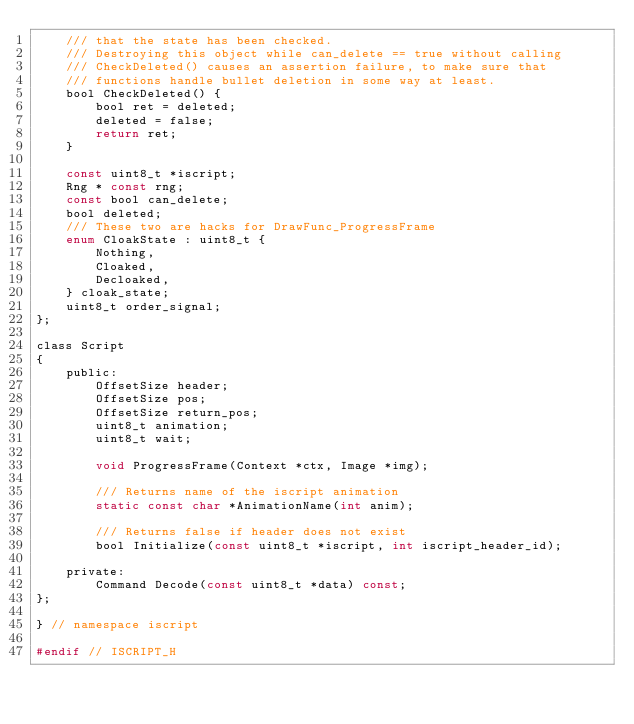<code> <loc_0><loc_0><loc_500><loc_500><_C_>    /// that the state has been checked.
    /// Destroying this object while can_delete == true without calling
    /// CheckDeleted() causes an assertion failure, to make sure that
    /// functions handle bullet deletion in some way at least.
    bool CheckDeleted() {
        bool ret = deleted;
        deleted = false;
        return ret;
    }

    const uint8_t *iscript;
    Rng * const rng;
    const bool can_delete;
    bool deleted;
    /// These two are hacks for DrawFunc_ProgressFrame
    enum CloakState : uint8_t {
        Nothing,
        Cloaked,
        Decloaked,
    } cloak_state;
    uint8_t order_signal;
};

class Script
{
    public:
        OffsetSize header;
        OffsetSize pos;
        OffsetSize return_pos;
        uint8_t animation;
        uint8_t wait;

        void ProgressFrame(Context *ctx, Image *img);

        /// Returns name of the iscript animation
        static const char *AnimationName(int anim);

        /// Returns false if header does not exist
        bool Initialize(const uint8_t *iscript, int iscript_header_id);

    private:
        Command Decode(const uint8_t *data) const;
};

} // namespace iscript

#endif // ISCRIPT_H
</code> 